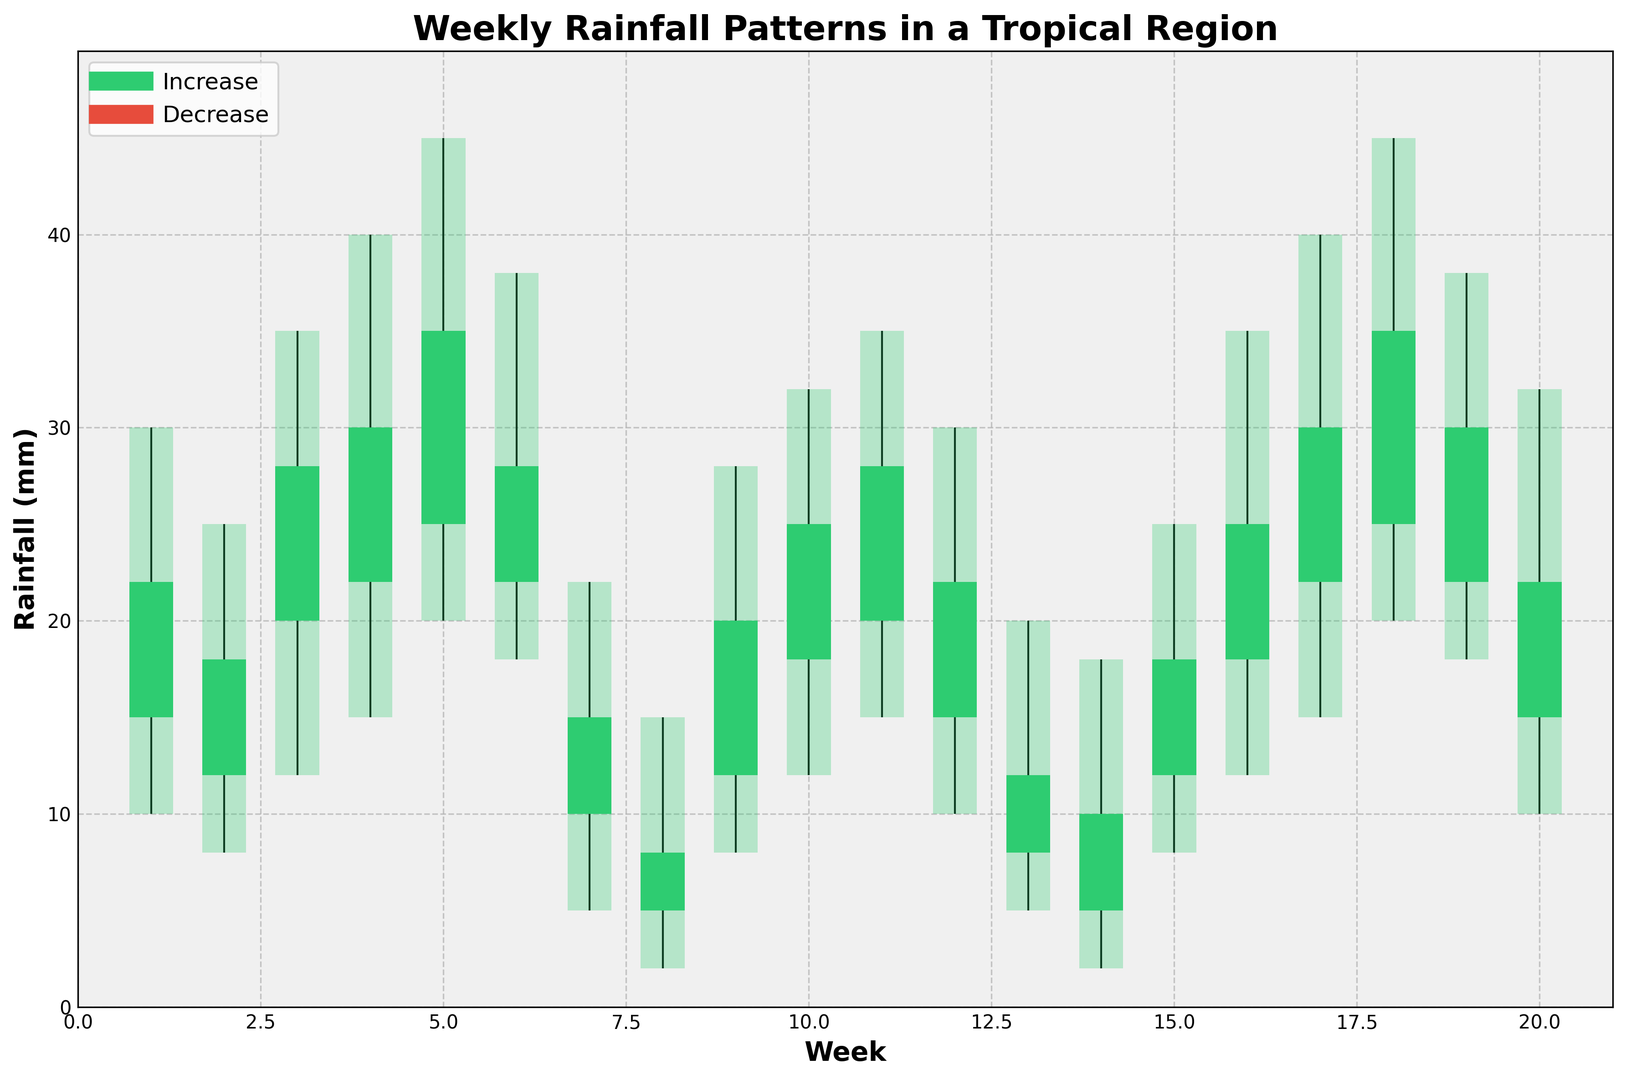Week 3 has the highest maximum rainfall. What is its value? To find the highest maximum rainfall value for Week 3, locate the Week 3 bar and check the top value. The maximum rainfall for Week 3 is 35 mm
Answer: 35 mm In which week did the minimum rainfall drop to its lowest level, and what was that level? To determine the week with the lowest minimum rainfall, look for the shortest bar at the bottom. The lowest minimum rainfall occurs in Week 8, with a value of 2 mm
Answer: Week 8, 2 mm Which week shows the largest increase in rainfall? To find the week with the largest increase in rainfall, identify the green bar with the greatest height from the bottom of the open value to the top of the close value. This occurs in Week 6 from 22 mm to 28 mm, which is an increase of 6 mm
Answer: Week 6, increase of 6 mm Compare the open and close rainfall values for Week 5. Which one is higher? To compare the open and close values for Week 5, check the green bar for Week 5. The open value is 25 mm and the close value is 35 mm. The close value is higher
Answer: Close value What is the average maximum rainfall over the first 4 weeks? To find the average maximum rainfall over the first 4 weeks, sum the maximum values for Week 1 to Week 4 (30 + 25 + 35 + 40 = 130 mm) and divide by 4. The average maximum rainfall is 130/4 = 32.5 mm
Answer: 32.5 mm Which weeks have a decreasing rainfall trend? To identify weeks with a decreasing rainfall trend, look for red bars. The weeks with decreasing rainfall trends are Week 7, Week 8, Week 13, and Week 14
Answer: Weeks 7, 8, 13, 14 What is the difference between the maximum and minimum rainfall in Week 10? To find the difference between the maximum and minimum rainfall in Week 10, subtract the minimum value from the maximum value (32 - 12 = 20 mm)
Answer: 20 mm Which week has the highest minimum rainfall value, and what is it? To determine the week with the highest minimum rainfall, look for the tallest bar starting from the bottom. The highest minimum rainfall value is in Week 18, with a value of 20 mm
Answer: Week 18, 20 mm If you sum the maximum rainfall values of Week 11 and Week 17, what is the total? Add the maximum rainfall values of Week 11 and Week 17 (35 + 40 = 75 mm)
Answer: 75 mm 